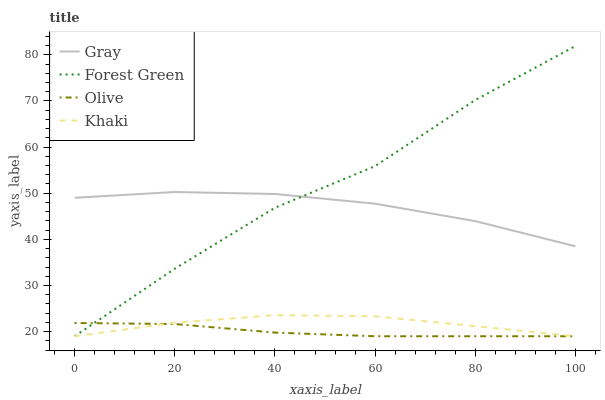Does Olive have the minimum area under the curve?
Answer yes or no. Yes. Does Forest Green have the maximum area under the curve?
Answer yes or no. Yes. Does Gray have the minimum area under the curve?
Answer yes or no. No. Does Gray have the maximum area under the curve?
Answer yes or no. No. Is Olive the smoothest?
Answer yes or no. Yes. Is Forest Green the roughest?
Answer yes or no. Yes. Is Gray the smoothest?
Answer yes or no. No. Is Gray the roughest?
Answer yes or no. No. Does Gray have the lowest value?
Answer yes or no. No. Does Forest Green have the highest value?
Answer yes or no. Yes. Does Gray have the highest value?
Answer yes or no. No. Is Khaki less than Gray?
Answer yes or no. Yes. Is Gray greater than Olive?
Answer yes or no. Yes. Does Gray intersect Forest Green?
Answer yes or no. Yes. Is Gray less than Forest Green?
Answer yes or no. No. Is Gray greater than Forest Green?
Answer yes or no. No. Does Khaki intersect Gray?
Answer yes or no. No. 